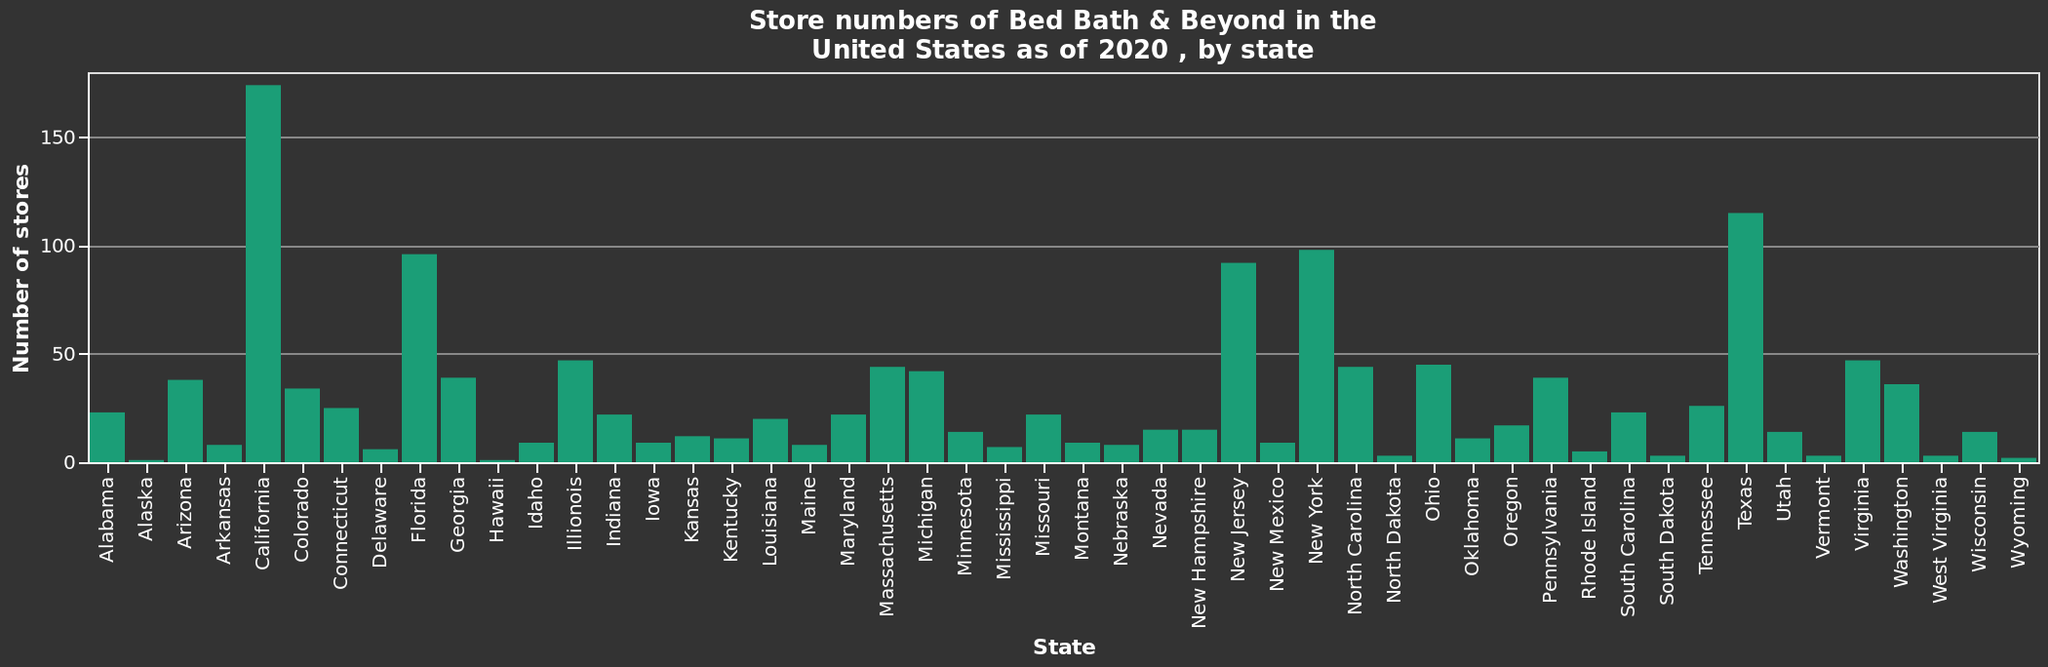<image>
Are there any Bed Bath & Beyond stores in Alaska? Yes, but it is mentioned that Alaska has the least number of stores. please describe the details of the chart This is a bar graph called Store numbers of Bed Bath & Beyond in the United States as of 2020 , by state. The x-axis measures State along a categorical scale starting at Alabama and ending at Wyoming. Number of stores is drawn on a linear scale from 0 to 150 along the y-axis. How many Bed Bath & Beyond stores are there in the United States as of 2020?  There are a total of [insert number] Bed Bath & Beyond stores in the United States as of 2020. 